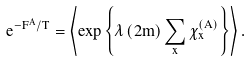Convert formula to latex. <formula><loc_0><loc_0><loc_500><loc_500>e ^ { - F ^ { A } / T } = \left \langle \exp \left \{ \lambda \left ( 2 m \right ) \sum _ { x } \chi _ { x } ^ { \left ( A \right ) } \right \} \right \rangle .</formula> 